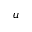Convert formula to latex. <formula><loc_0><loc_0><loc_500><loc_500>u</formula> 